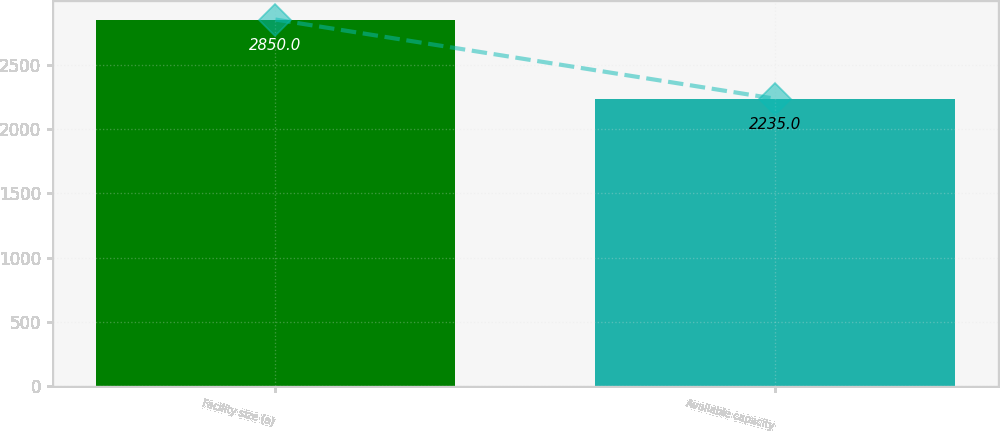<chart> <loc_0><loc_0><loc_500><loc_500><bar_chart><fcel>Facility size (a)<fcel>Available capacity<nl><fcel>2850<fcel>2235<nl></chart> 